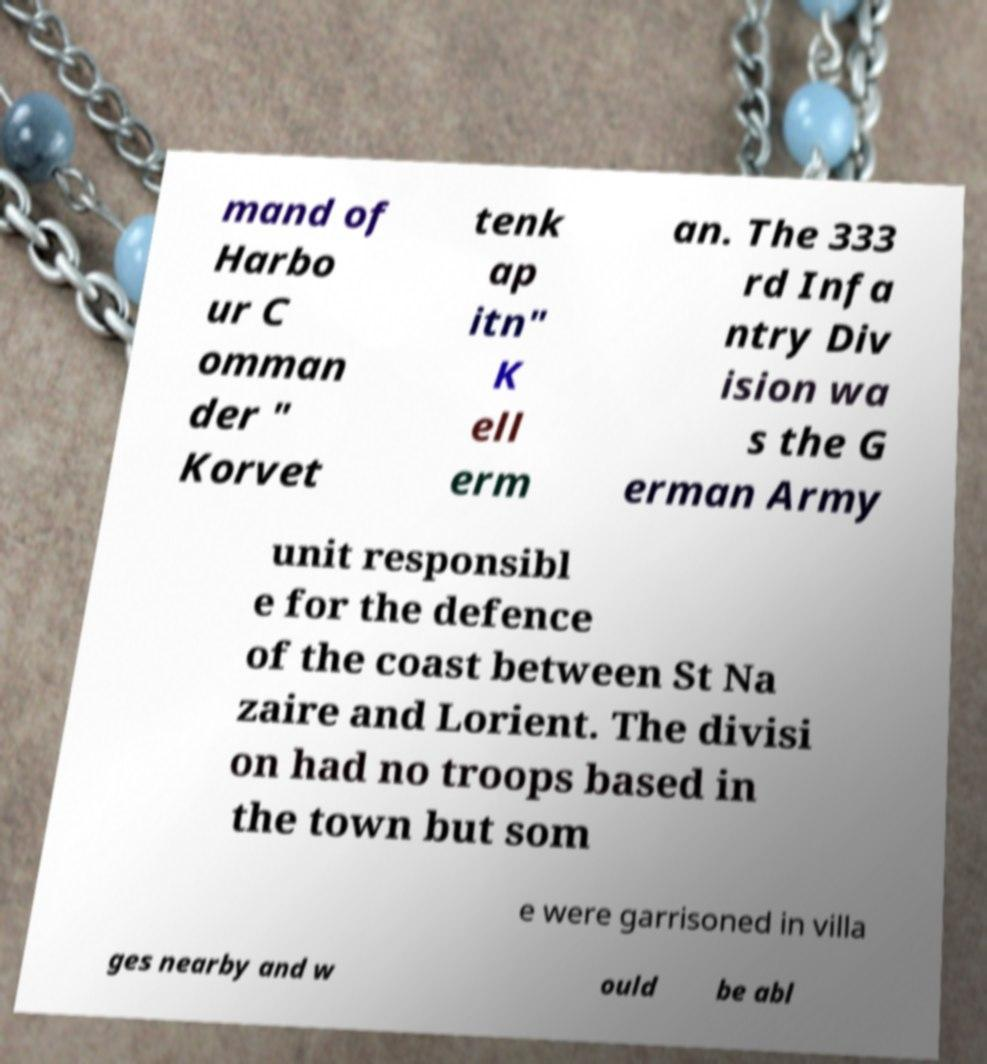Could you assist in decoding the text presented in this image and type it out clearly? mand of Harbo ur C omman der " Korvet tenk ap itn" K ell erm an. The 333 rd Infa ntry Div ision wa s the G erman Army unit responsibl e for the defence of the coast between St Na zaire and Lorient. The divisi on had no troops based in the town but som e were garrisoned in villa ges nearby and w ould be abl 